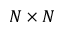Convert formula to latex. <formula><loc_0><loc_0><loc_500><loc_500>N \times N</formula> 